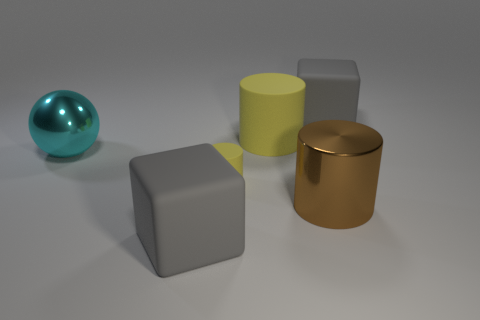There is a brown object that is the same shape as the tiny yellow thing; what material is it? metal 